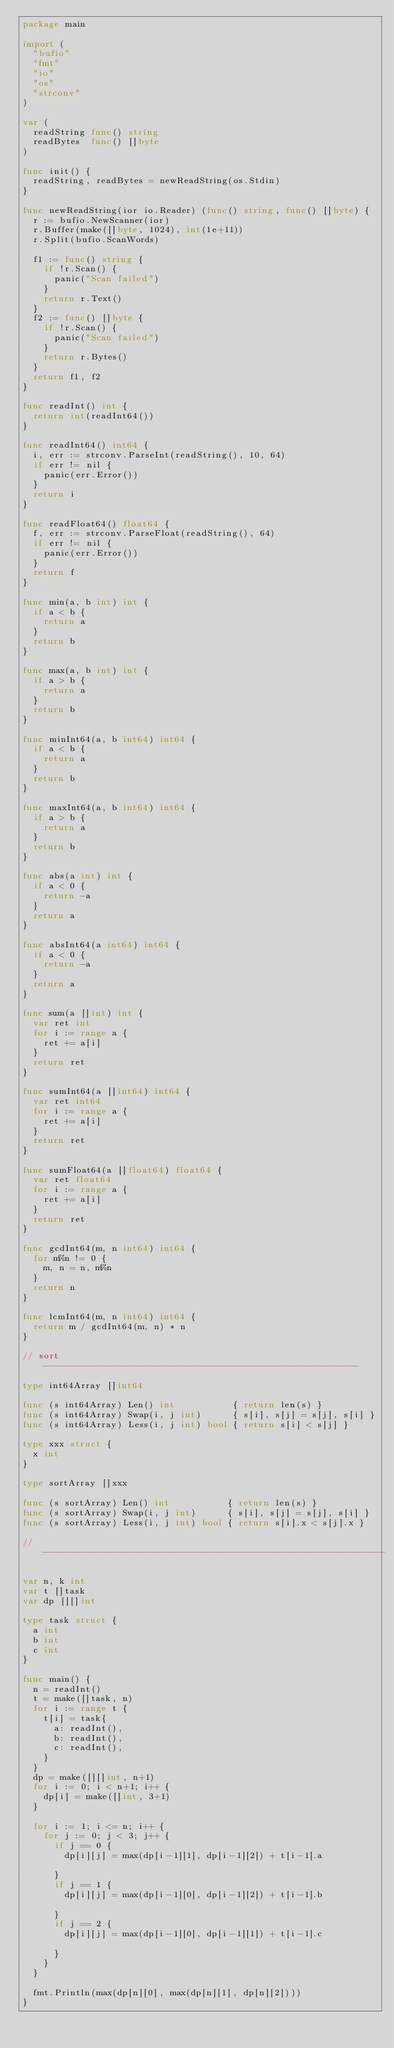<code> <loc_0><loc_0><loc_500><loc_500><_Go_>package main

import (
	"bufio"
	"fmt"
	"io"
	"os"
	"strconv"
)

var (
	readString func() string
	readBytes  func() []byte
)

func init() {
	readString, readBytes = newReadString(os.Stdin)
}

func newReadString(ior io.Reader) (func() string, func() []byte) {
	r := bufio.NewScanner(ior)
	r.Buffer(make([]byte, 1024), int(1e+11))
	r.Split(bufio.ScanWords)

	f1 := func() string {
		if !r.Scan() {
			panic("Scan failed")
		}
		return r.Text()
	}
	f2 := func() []byte {
		if !r.Scan() {
			panic("Scan failed")
		}
		return r.Bytes()
	}
	return f1, f2
}

func readInt() int {
	return int(readInt64())
}

func readInt64() int64 {
	i, err := strconv.ParseInt(readString(), 10, 64)
	if err != nil {
		panic(err.Error())
	}
	return i
}

func readFloat64() float64 {
	f, err := strconv.ParseFloat(readString(), 64)
	if err != nil {
		panic(err.Error())
	}
	return f
}

func min(a, b int) int {
	if a < b {
		return a
	}
	return b
}

func max(a, b int) int {
	if a > b {
		return a
	}
	return b
}

func minInt64(a, b int64) int64 {
	if a < b {
		return a
	}
	return b
}

func maxInt64(a, b int64) int64 {
	if a > b {
		return a
	}
	return b
}

func abs(a int) int {
	if a < 0 {
		return -a
	}
	return a
}

func absInt64(a int64) int64 {
	if a < 0 {
		return -a
	}
	return a
}

func sum(a []int) int {
	var ret int
	for i := range a {
		ret += a[i]
	}
	return ret
}

func sumInt64(a []int64) int64 {
	var ret int64
	for i := range a {
		ret += a[i]
	}
	return ret
}

func sumFloat64(a []float64) float64 {
	var ret float64
	for i := range a {
		ret += a[i]
	}
	return ret
}

func gcdInt64(m, n int64) int64 {
	for m%n != 0 {
		m, n = n, m%n
	}
	return n
}

func lcmInt64(m, n int64) int64 {
	return m / gcdInt64(m, n) * n
}

// sort ------------------------------------------------------------

type int64Array []int64

func (s int64Array) Len() int           { return len(s) }
func (s int64Array) Swap(i, j int)      { s[i], s[j] = s[j], s[i] }
func (s int64Array) Less(i, j int) bool { return s[i] < s[j] }

type xxx struct {
	x int
}

type sortArray []xxx

func (s sortArray) Len() int           { return len(s) }
func (s sortArray) Swap(i, j int)      { s[i], s[j] = s[j], s[i] }
func (s sortArray) Less(i, j int) bool { return s[i].x < s[j].x }

// -----------------------------------------------------------------

var n, k int
var t []task
var dp [][]int

type task struct {
	a int
	b int
	c int
}

func main() {
	n = readInt()
	t = make([]task, n)
	for i := range t {
		t[i] = task{
			a: readInt(),
			b: readInt(),
			c: readInt(),
		}
	}
	dp = make([][]int, n+1)
	for i := 0; i < n+1; i++ {
		dp[i] = make([]int, 3+1)
	}

	for i := 1; i <= n; i++ {
		for j := 0; j < 3; j++ {
			if j == 0 {
				dp[i][j] = max(dp[i-1][1], dp[i-1][2]) + t[i-1].a

			}
			if j == 1 {
				dp[i][j] = max(dp[i-1][0], dp[i-1][2]) + t[i-1].b

			}
			if j == 2 {
				dp[i][j] = max(dp[i-1][0], dp[i-1][1]) + t[i-1].c

			}
		}
	}

	fmt.Println(max(dp[n][0], max(dp[n][1], dp[n][2])))
}
</code> 